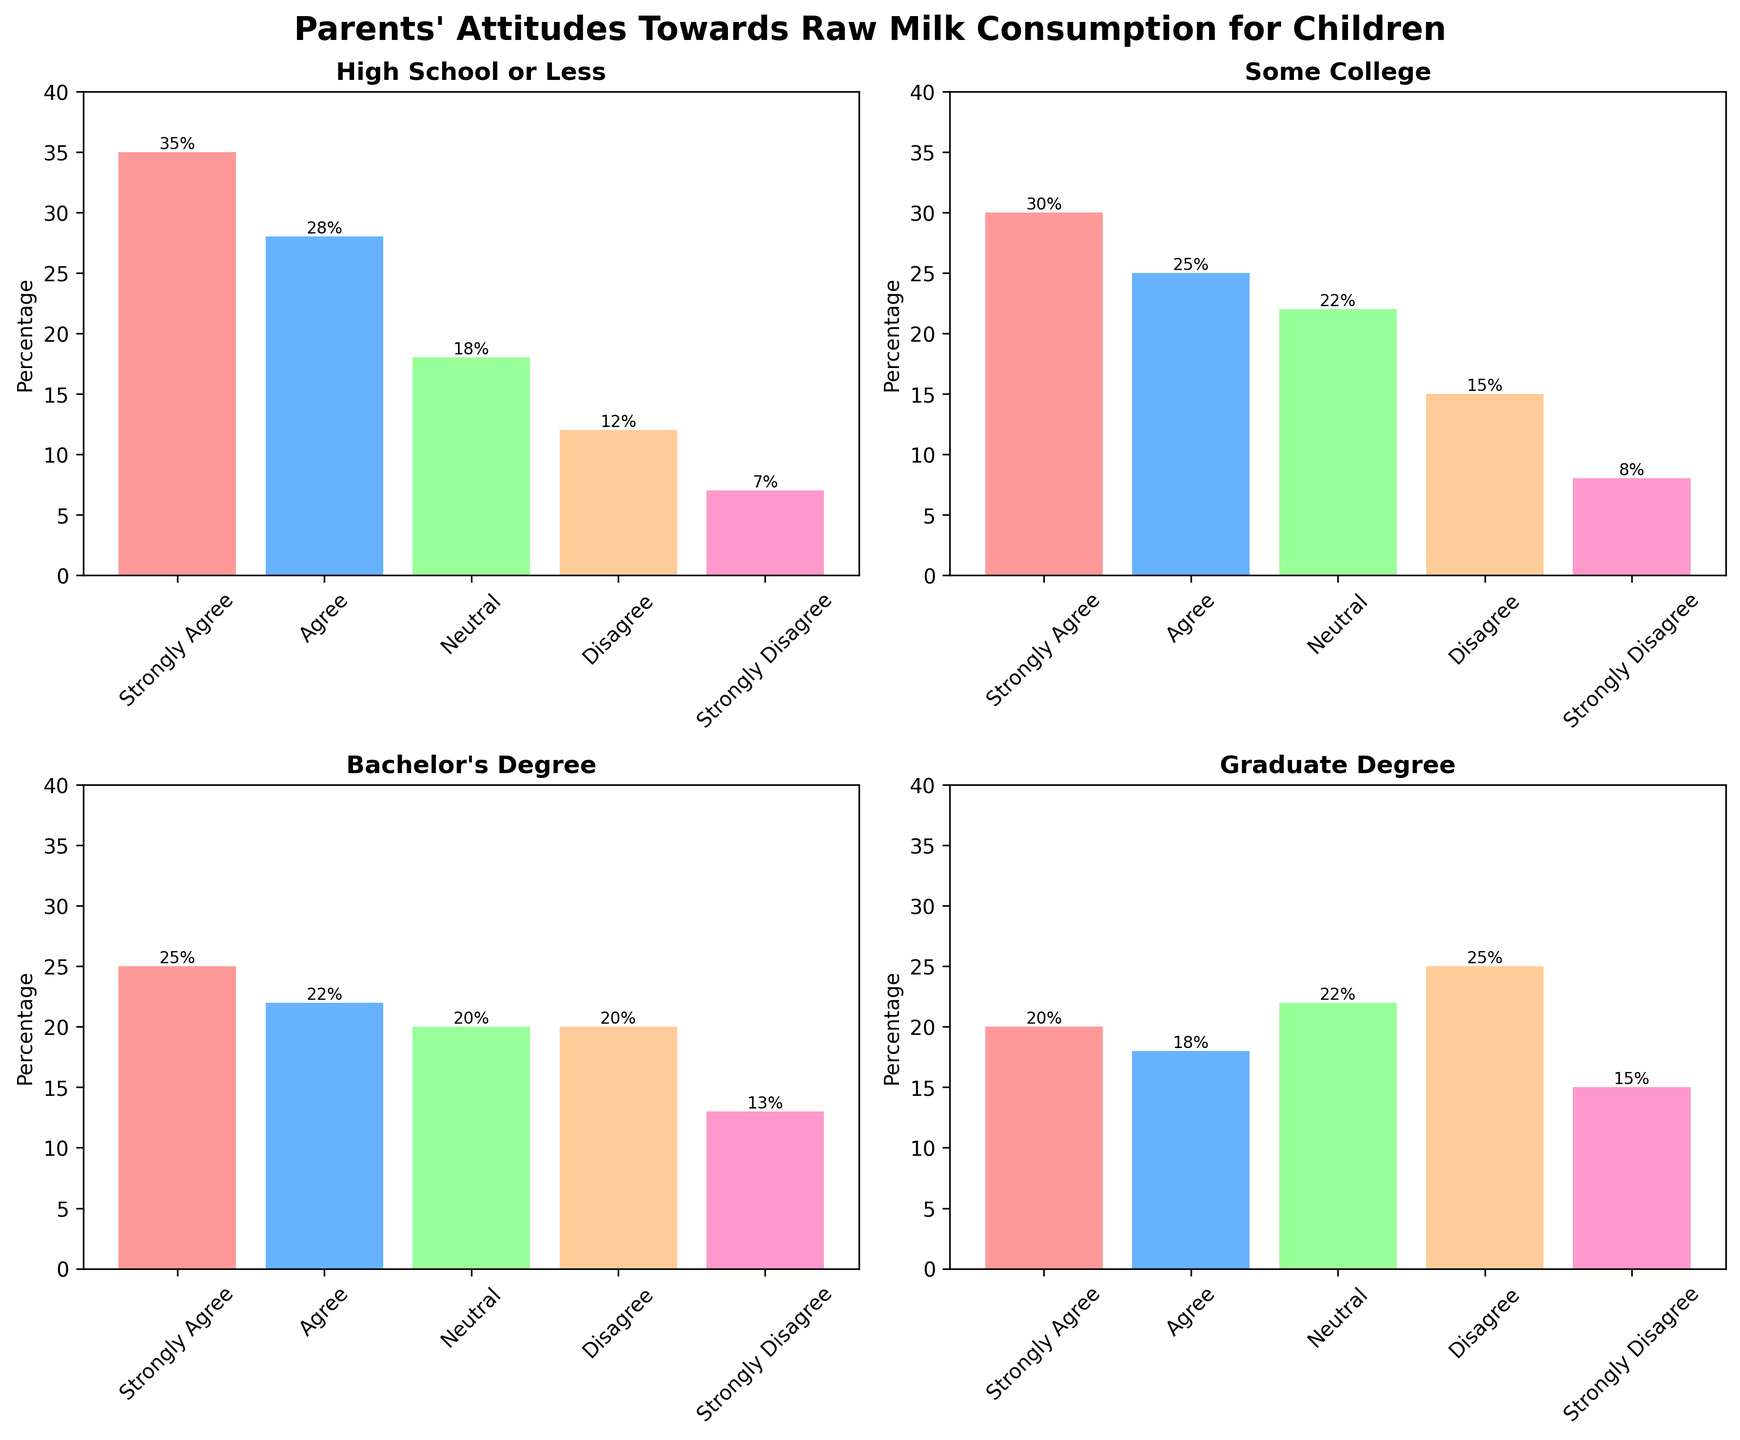How many education levels are represented in the figure? The figure shows subplots for each education level, and there are four subplots representing different education levels.
Answer: Four What percentage of parents with a High School or Less education level strongly agree with raw milk consumption for children? In the subplot titled "High School or Less," the bar for 'Strongly Agree' shows a height of 35%.
Answer: 35% Which education level has the highest percentage of parents who strongly disagree with raw milk consumption for children? By comparing the height of the 'Strongly Disagree' bars across all four subplots, the Graduate Degree subgroup has the highest percentage, which is 15%.
Answer: Graduate Degree How does the percentage of parents who agree with raw milk consumption vary between High School or Less and Bachelor's Degree education levels? For High School or Less, the percentage is shown to be 28%, while for Bachelor's Degree, it is 22%. The difference can be calculated as 28% - 22% = 6%.
Answer: 6% What is the more common attitude among parents with Some College education: being neutral or disagreeing about raw milk consumption? In the subplot for Some College, the 'Neutral' bar has a height of 22%, while the 'Disagree' bar is at 15%. Therefore, being neutral is more common.
Answer: Neutral Which education level shows the least agreement (both 'Agree' and 'Strongly Agree' combined) with raw milk consumption for children? Summing up 'Agree' and 'Strongly Agree' for each level: 
- High School or Less: 35% + 28% = 63%
- Some College: 30% + 25% = 55%
- Bachelor's Degree: 25% + 22% = 47%
- Graduate Degree: 20% + 18% = 38%
Graduate Degree has the least agreement with 38%.
Answer: Graduate Degree What is the sum of the neutral responses across all education levels? Adding the 'Neutral' percentages for all levels: 
- High School or Less: 18%
- Some College: 22%
- Bachelor's Degree: 20%
- Graduate Degree: 22%
The total is 18% + 22% + 20% + 22% = 82%.
Answer: 82% Compare the percentage of parents with a Graduate Degree and parents with a High School or Less education that disagree with raw milk consumption for children. Who has a higher percentage and by how much? Looking at the 'Disagree' bars:
- Graduate Degree: 25%
- High School or Less: 12%
The Graduate Degree group has a higher percentage by 25% - 12% = 13%.
Answer: Graduate Degree, by 13% What is the average percentage of parents who strongly agree on raw milk consumption for children across all education levels? The 'Strongly Agree' percentages are: 35% (High School or Less), 30% (Some College), 25% (Bachelor's Degree), 20% (Graduate Degree). The sum is 35% + 30% + 25% + 20% = 110%. The average is 110% / 4 = 27.5%.
Answer: 27.5% In which education level is the combined percentage of disagree and strongly disagree parents highest? Adding 'Disagree' and 'Strongly Disagree' for each level:
- High School or Less: 12% + 7% = 19%
- Some College: 15% + 8% = 23%
- Bachelor's Degree: 20% + 13% = 33%
- Graduate Degree: 25% + 15% = 40%
The highest combined percentage is in the Graduate Degree group with 40%.
Answer: Graduate Degree 